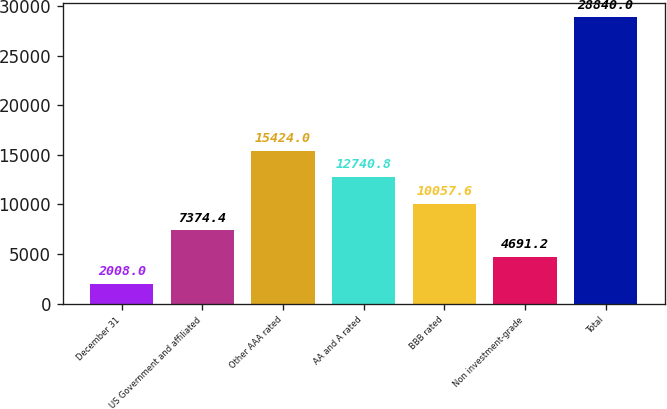<chart> <loc_0><loc_0><loc_500><loc_500><bar_chart><fcel>December 31<fcel>US Government and affiliated<fcel>Other AAA rated<fcel>AA and A rated<fcel>BBB rated<fcel>Non investment-grade<fcel>Total<nl><fcel>2008<fcel>7374.4<fcel>15424<fcel>12740.8<fcel>10057.6<fcel>4691.2<fcel>28840<nl></chart> 